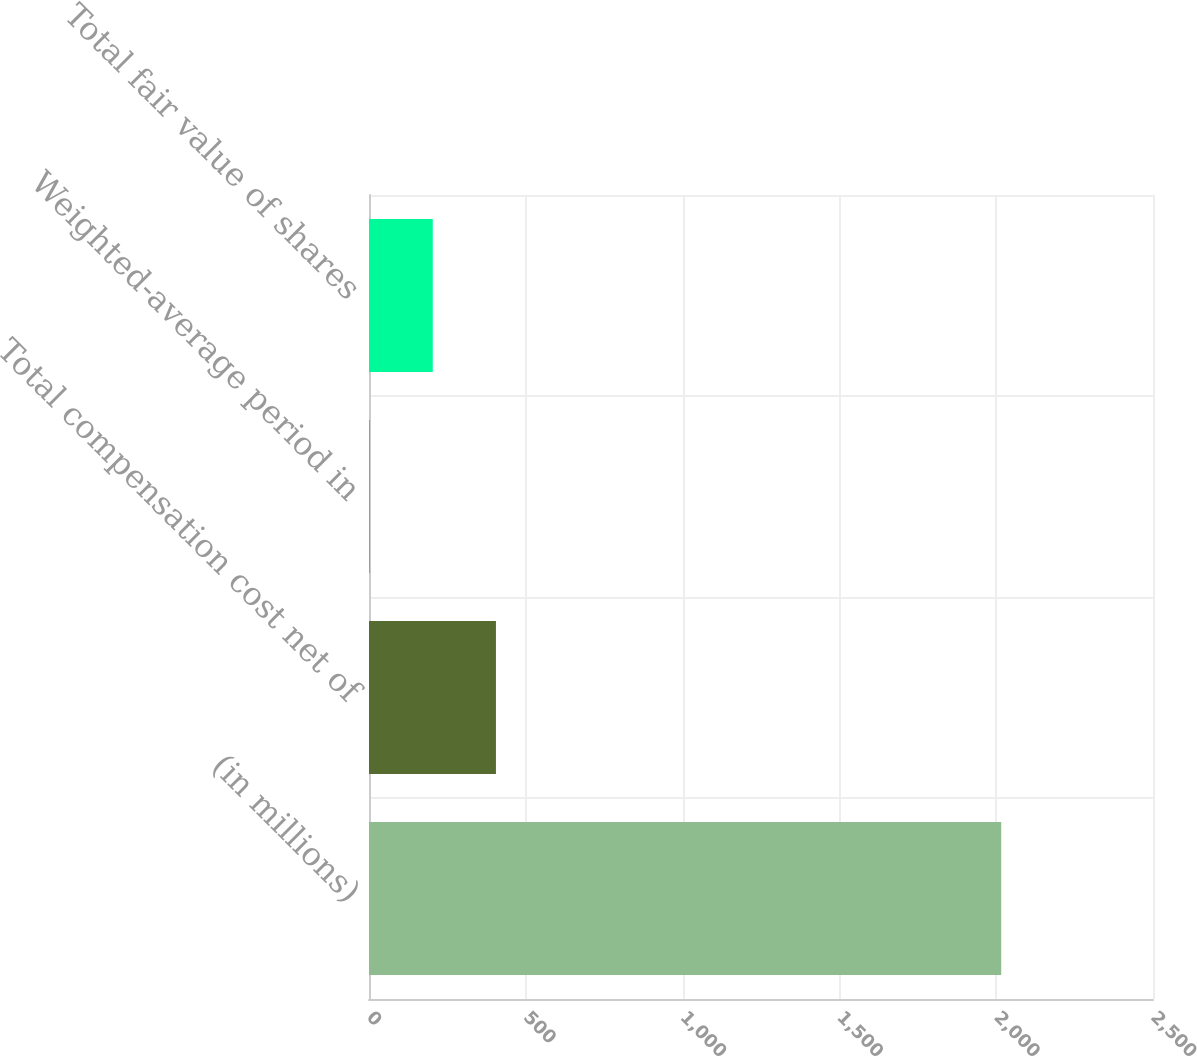Convert chart to OTSL. <chart><loc_0><loc_0><loc_500><loc_500><bar_chart><fcel>(in millions)<fcel>Total compensation cost net of<fcel>Weighted-average period in<fcel>Total fair value of shares<nl><fcel>2016<fcel>404.8<fcel>2<fcel>203.4<nl></chart> 